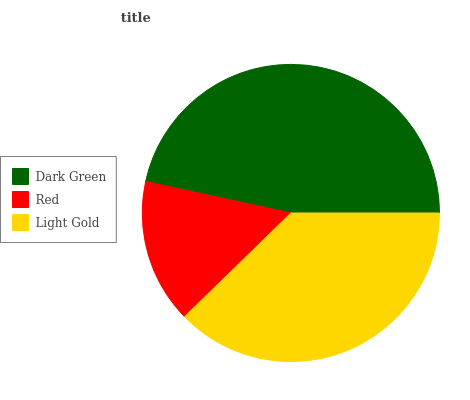Is Red the minimum?
Answer yes or no. Yes. Is Dark Green the maximum?
Answer yes or no. Yes. Is Light Gold the minimum?
Answer yes or no. No. Is Light Gold the maximum?
Answer yes or no. No. Is Light Gold greater than Red?
Answer yes or no. Yes. Is Red less than Light Gold?
Answer yes or no. Yes. Is Red greater than Light Gold?
Answer yes or no. No. Is Light Gold less than Red?
Answer yes or no. No. Is Light Gold the high median?
Answer yes or no. Yes. Is Light Gold the low median?
Answer yes or no. Yes. Is Dark Green the high median?
Answer yes or no. No. Is Red the low median?
Answer yes or no. No. 